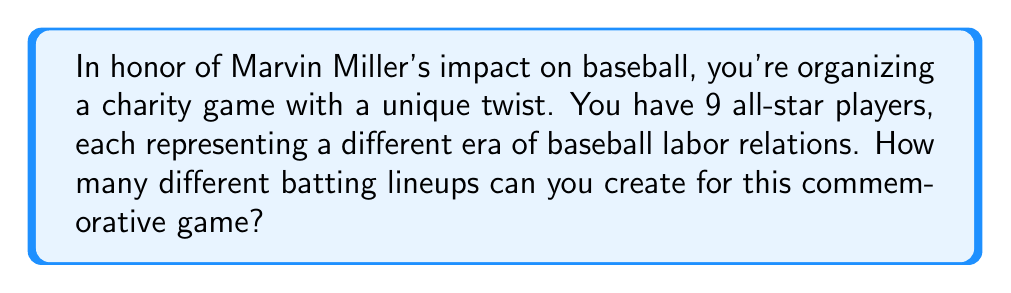Provide a solution to this math problem. Let's approach this step-by-step:

1) In baseball, a batting lineup consists of 9 players, each batting in a specific order.

2) This is a permutation problem, as the order matters (batting 1st is different from batting 9th) and we're using all 9 players.

3) The formula for permutations is:

   $$P(n,r) = \frac{n!}{(n-r)!}$$

   Where $n$ is the total number of items to choose from, and $r$ is the number of items being arranged.

4) In this case, $n = 9$ (total players) and $r = 9$ (all players are in the lineup).

5) Plugging these numbers into our formula:

   $$P(9,9) = \frac{9!}{(9-9)!} = \frac{9!}{0!}$$

6) Remember, 0! is defined as 1, so this simplifies to:

   $$P(9,9) = 9!$$

7) Let's calculate 9!:

   $$9! = 9 \times 8 \times 7 \times 6 \times 5 \times 4 \times 3 \times 2 \times 1 = 362,880$$

Therefore, there are 362,880 different possible batting lineups for your commemorative game.
Answer: 362,880 